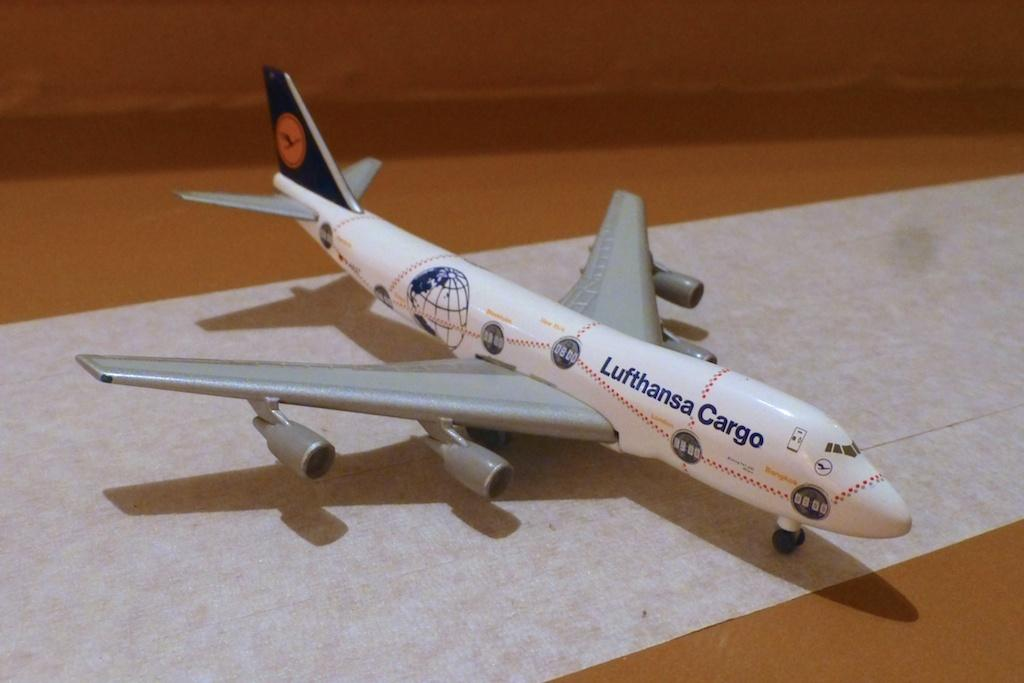<image>
Summarize the visual content of the image. a model plane of a Lufthansa Cargo jet 